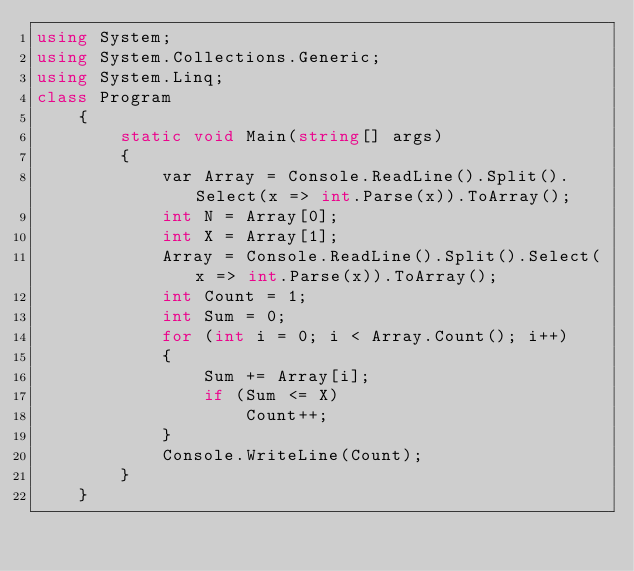Convert code to text. <code><loc_0><loc_0><loc_500><loc_500><_C#_>using System;
using System.Collections.Generic;
using System.Linq;   
class Program
    {
        static void Main(string[] args)
        {
            var Array = Console.ReadLine().Split().Select(x => int.Parse(x)).ToArray();
            int N = Array[0];
            int X = Array[1];
            Array = Console.ReadLine().Split().Select(x => int.Parse(x)).ToArray();
            int Count = 1;
            int Sum = 0;
            for (int i = 0; i < Array.Count(); i++)
            {
                Sum += Array[i];
                if (Sum <= X)
                    Count++;
            }
            Console.WriteLine(Count);
        }
    }</code> 